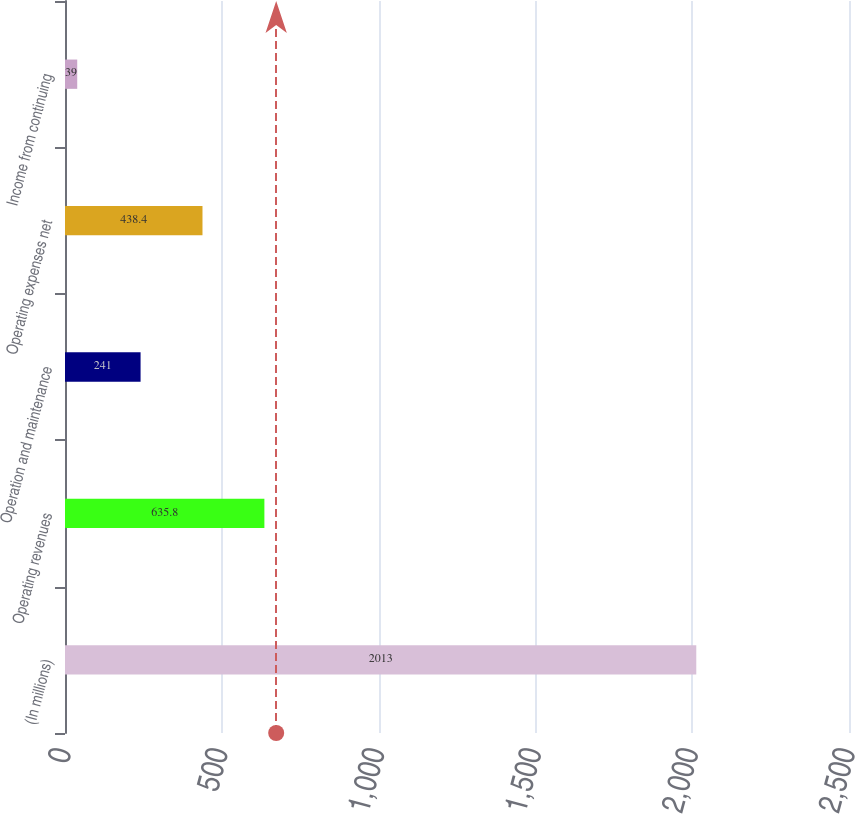Convert chart. <chart><loc_0><loc_0><loc_500><loc_500><bar_chart><fcel>(In millions)<fcel>Operating revenues<fcel>Operation and maintenance<fcel>Operating expenses net<fcel>Income from continuing<nl><fcel>2013<fcel>635.8<fcel>241<fcel>438.4<fcel>39<nl></chart> 